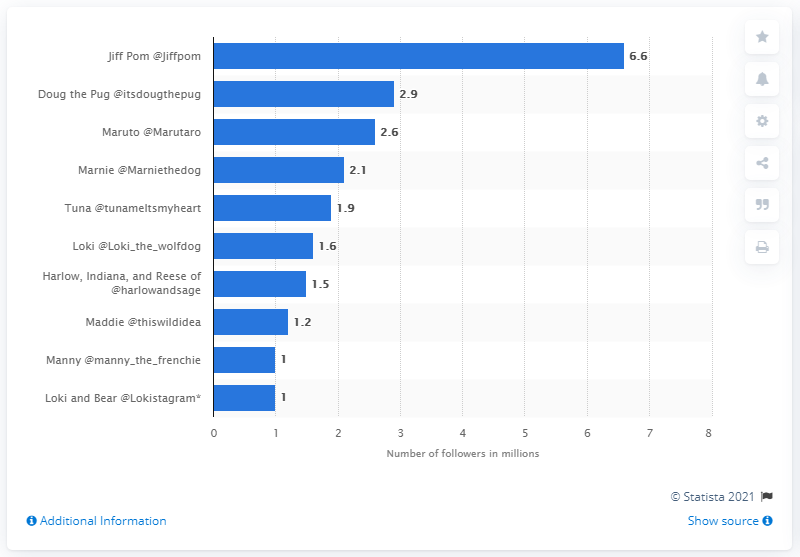Specify some key components in this picture. Jiff Pom had approximately 6.6 followers on Instagram. 